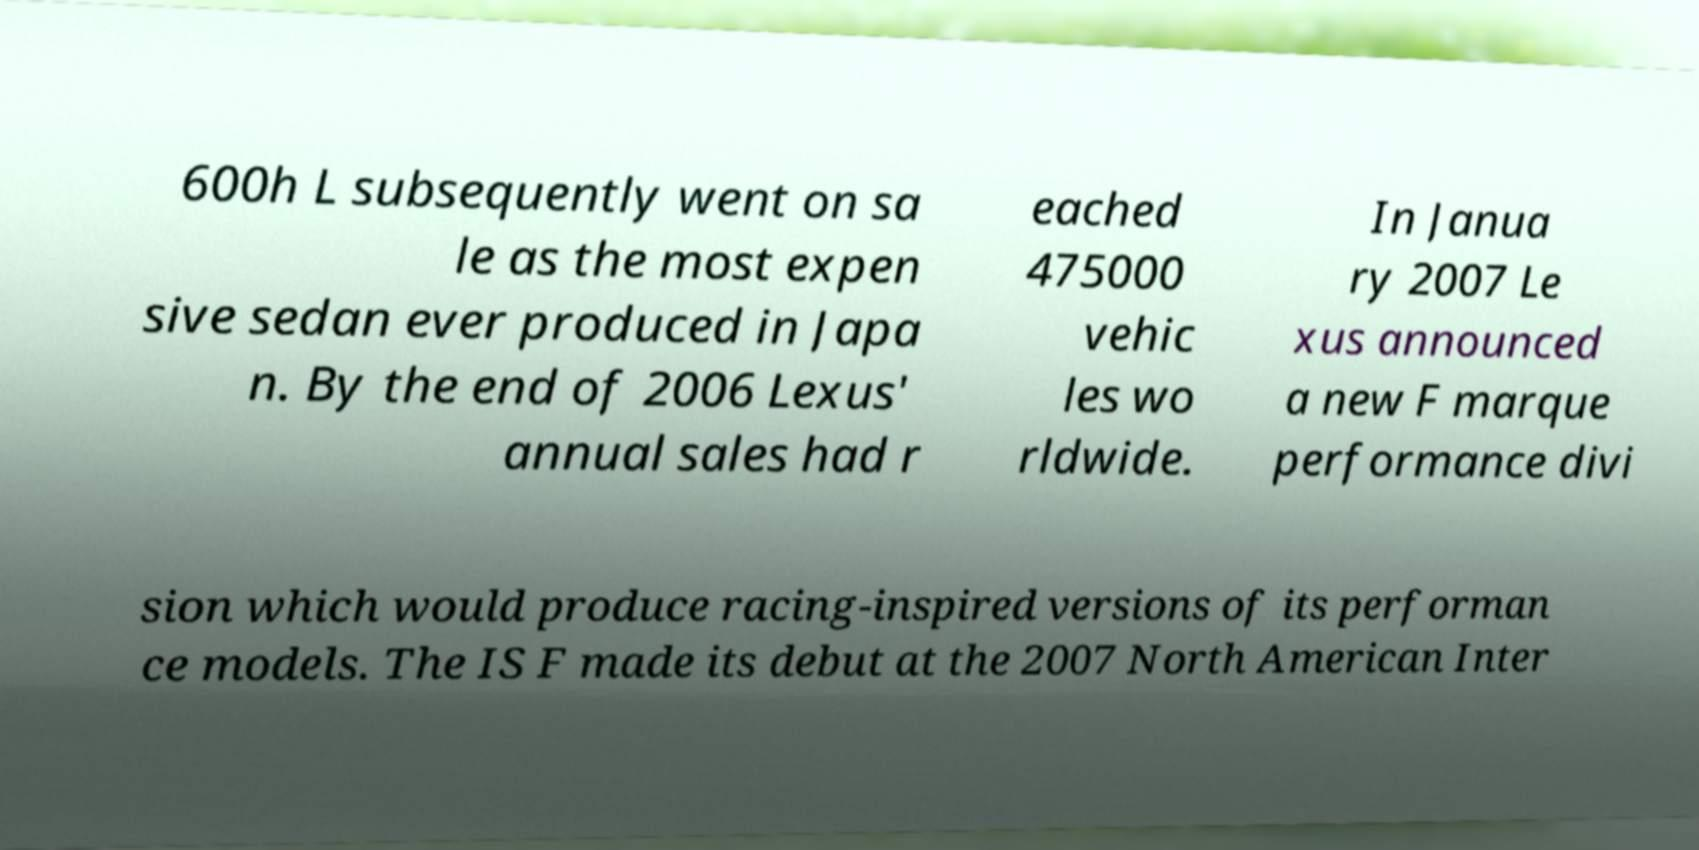What messages or text are displayed in this image? I need them in a readable, typed format. 600h L subsequently went on sa le as the most expen sive sedan ever produced in Japa n. By the end of 2006 Lexus' annual sales had r eached 475000 vehic les wo rldwide. In Janua ry 2007 Le xus announced a new F marque performance divi sion which would produce racing-inspired versions of its performan ce models. The IS F made its debut at the 2007 North American Inter 